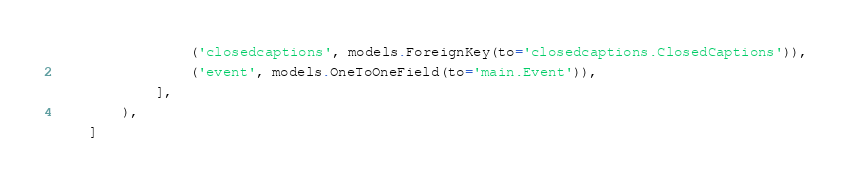Convert code to text. <code><loc_0><loc_0><loc_500><loc_500><_Python_>                ('closedcaptions', models.ForeignKey(to='closedcaptions.ClosedCaptions')),
                ('event', models.OneToOneField(to='main.Event')),
            ],
        ),
    ]
</code> 